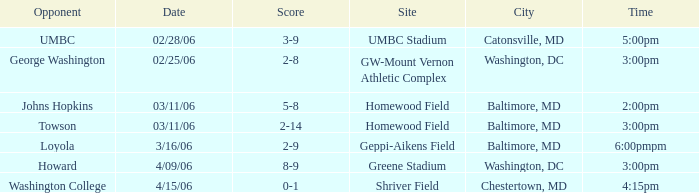Which site has a Score of 0-1? Shriver Field. 